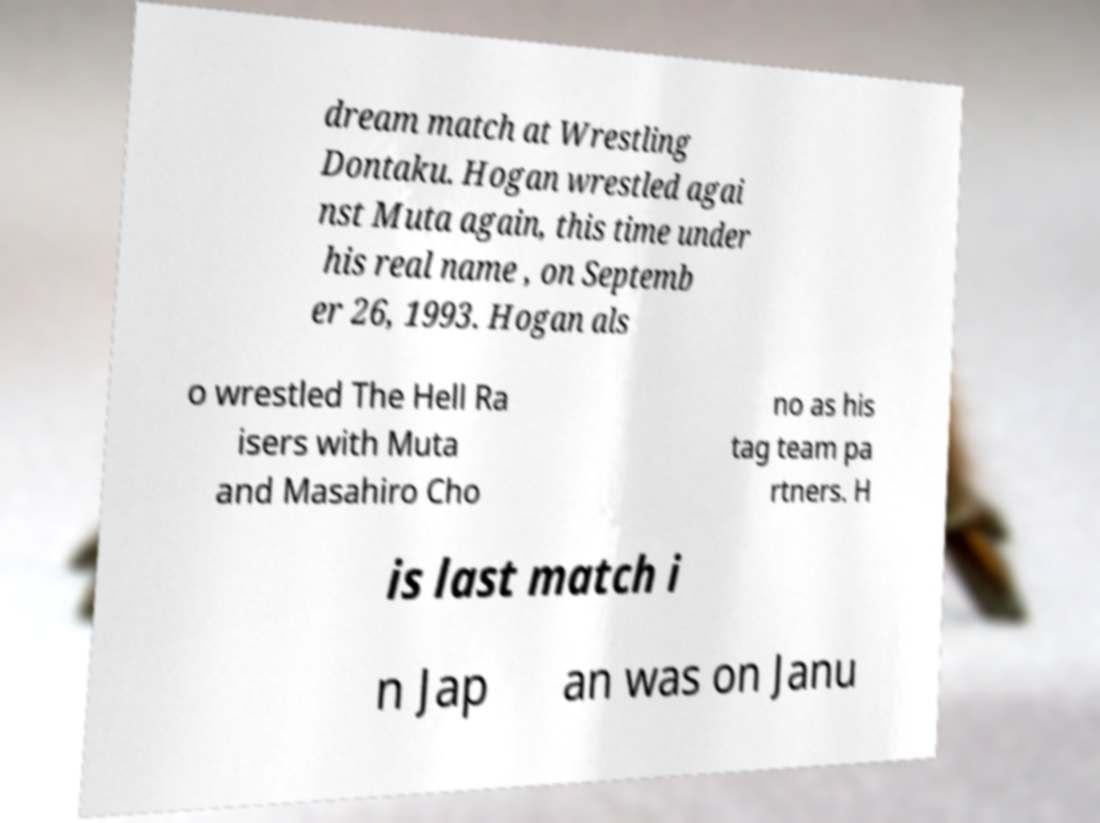Please read and relay the text visible in this image. What does it say? dream match at Wrestling Dontaku. Hogan wrestled agai nst Muta again, this time under his real name , on Septemb er 26, 1993. Hogan als o wrestled The Hell Ra isers with Muta and Masahiro Cho no as his tag team pa rtners. H is last match i n Jap an was on Janu 